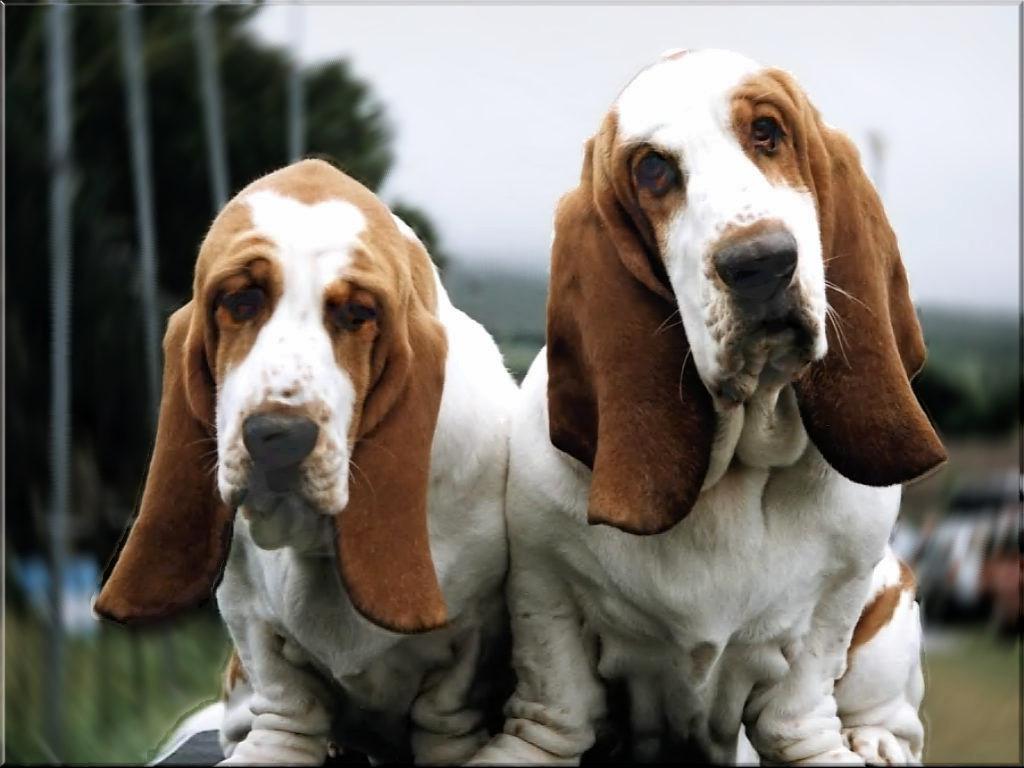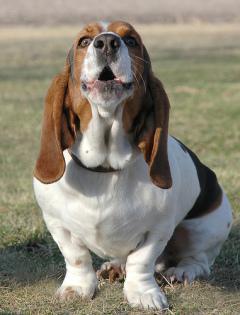The first image is the image on the left, the second image is the image on the right. Considering the images on both sides, is "There is a single hound outside in the grass in the right image." valid? Answer yes or no. Yes. The first image is the image on the left, the second image is the image on the right. Examine the images to the left and right. Is the description "bassett hounds are facing the camera" accurate? Answer yes or no. Yes. 